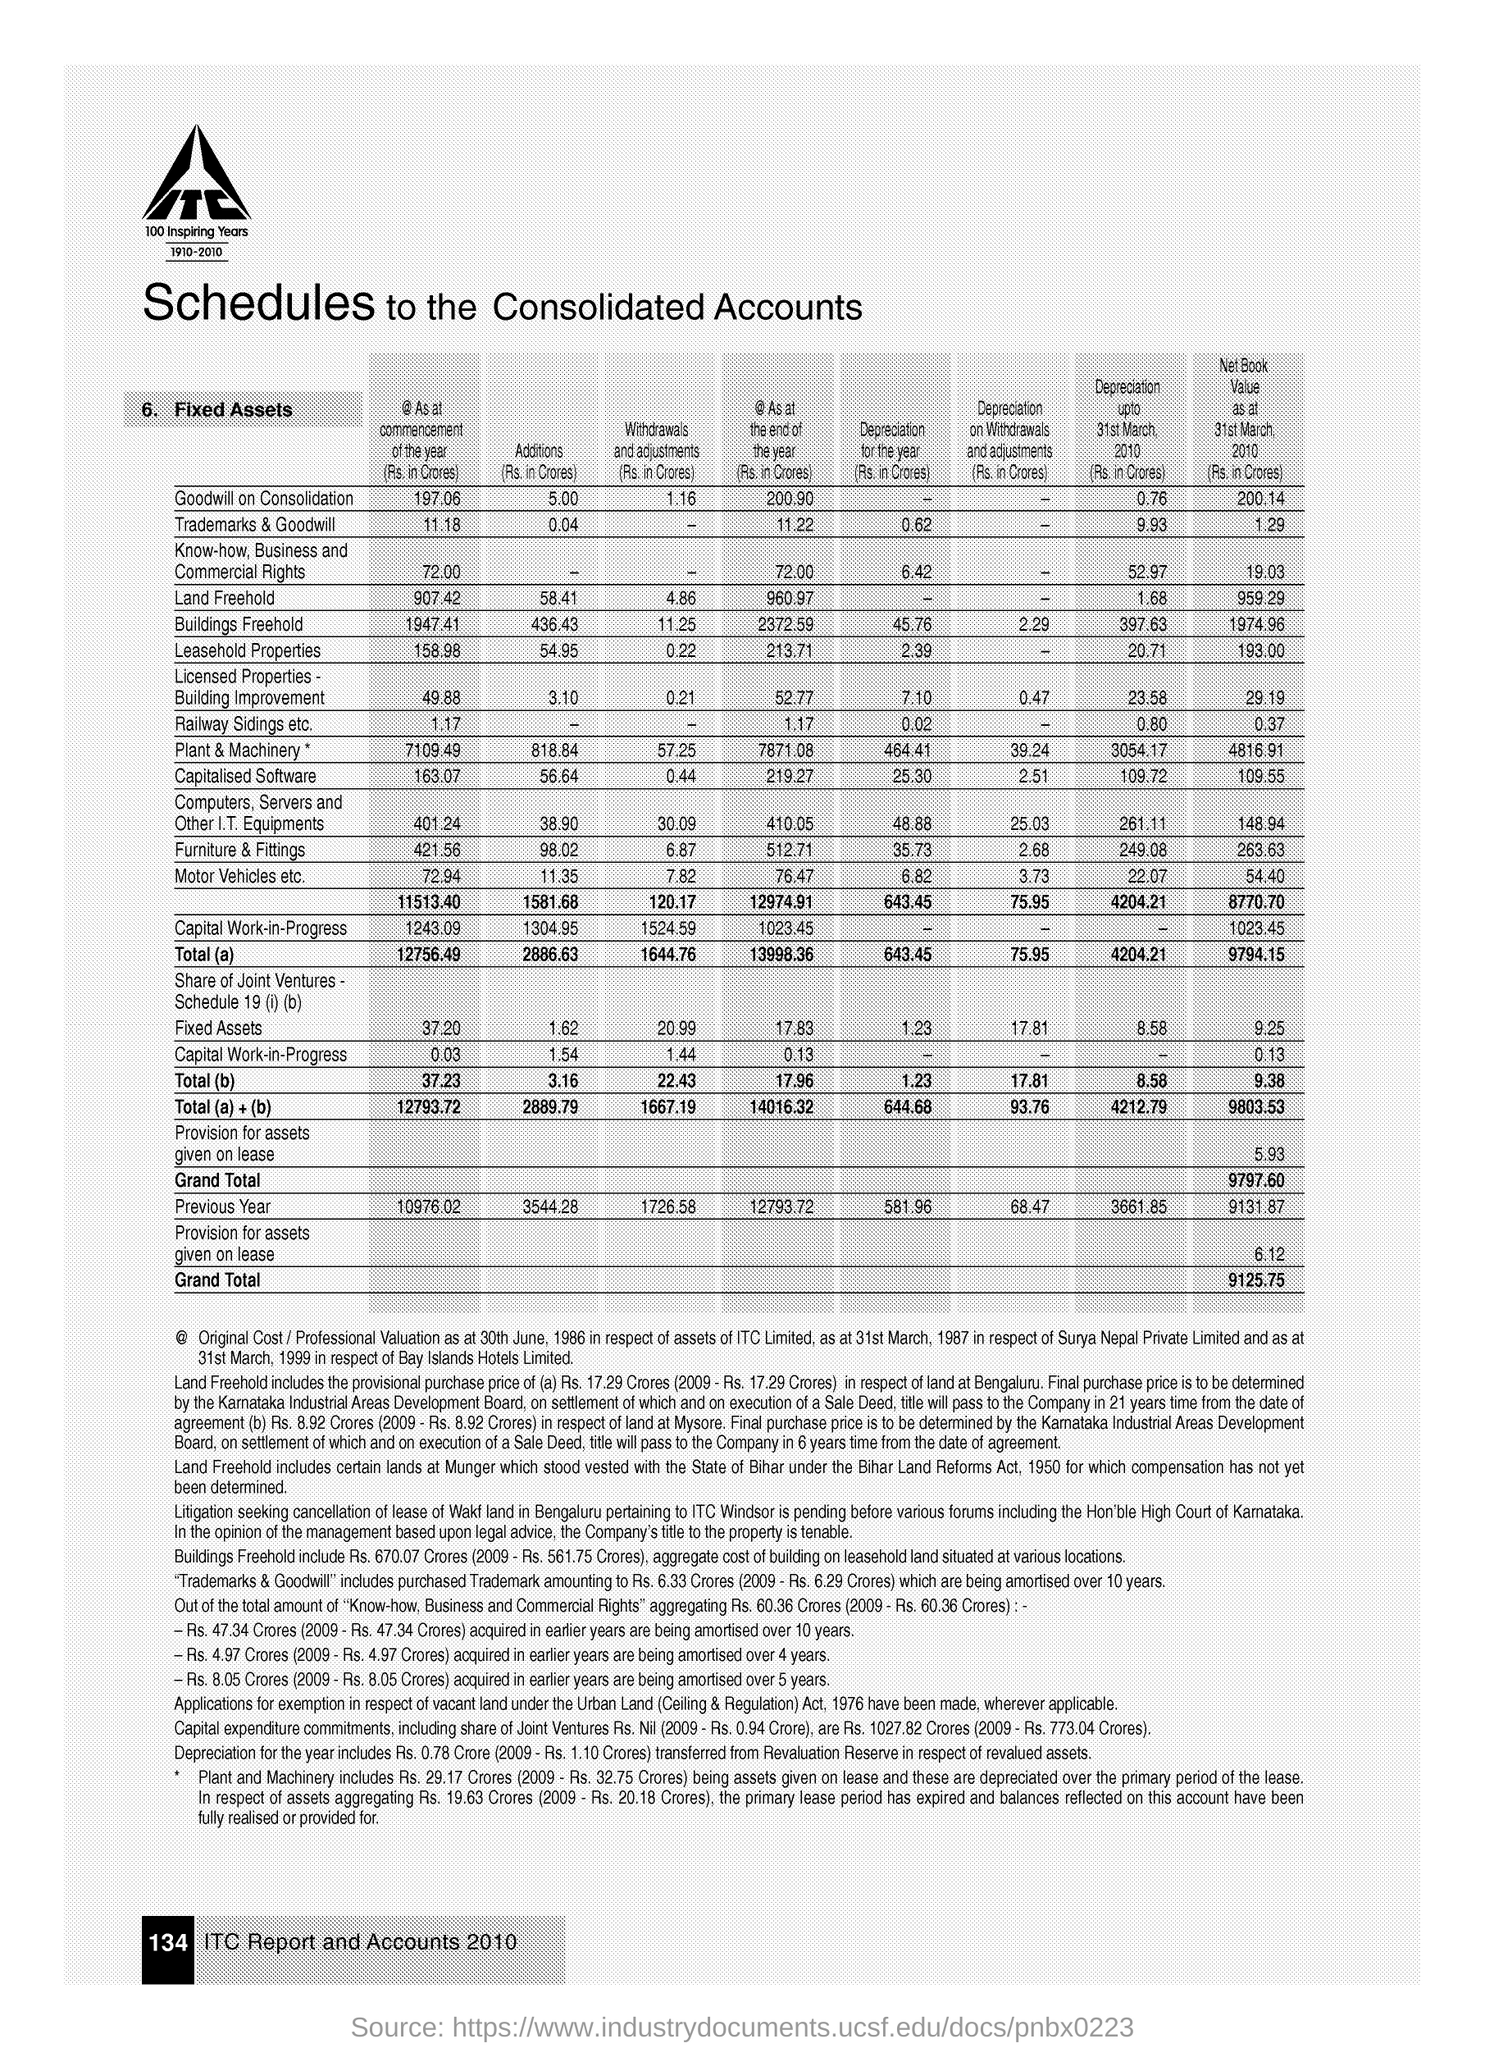What is the document title?
Provide a succinct answer. Schedules to the Consolidated Accounts. What is the Grand Total of Net Book Value as at 31st March, 2010 (Rs. in Crores)?
Provide a short and direct response. 9125.75. 